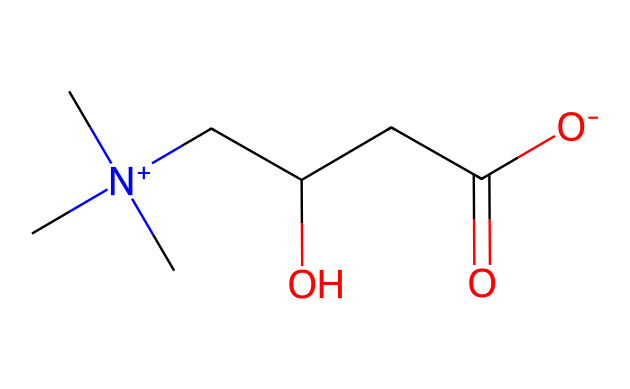What is the total number of carbon atoms in L-carnitine? By analyzing the SMILES representation, we count the 'C' symbols. There are a total of 7 carbon atoms in the structure.
Answer: seven How many oxygen atoms are present in the structure? In the given SMILES, 'O' symbols denote oxygen atoms. There are 2 oxygen atoms present in the L-carnitine structure.
Answer: two What is the charge of the nitrogen atom in L-carnitine? The '[N+]' notation indicates that the nitrogen atom carries a positive charge.
Answer: positive What type of functional groups are present in L-carnitine? The structure features a hydroxyl group (-OH) and a carboxyl group (-COOH), which are common functional groups for alcohols and acids, respectively.
Answer: hydroxyl and carboxyl Is L-carnitine categorized as a fatty acid? L-carnitine, while related to lipid metabolism, does not have the structural characteristics of fatty acids, which typically feature long hydrocarbon chains.
Answer: no Why is the chiral center important in L-carnitine? The presence of a chiral center allows L-carnitine to exist in two enantiomeric forms, which can have different biological activities; only the L-form is biologically active.
Answer: biological activity What role does L-carnitine play in fat metabolism? L-carnitine is essential for transporting fatty acids into the mitochondria for oxidation, which is critical for energy production from fats.
Answer: energy production 